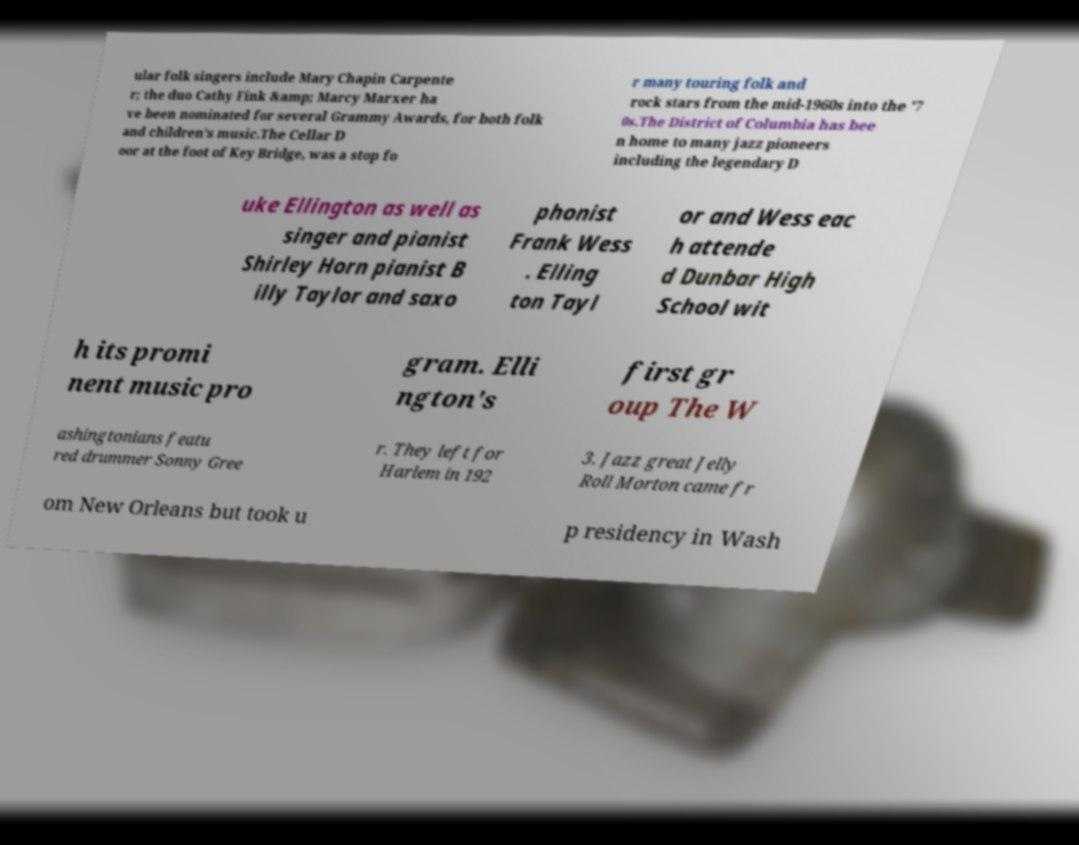There's text embedded in this image that I need extracted. Can you transcribe it verbatim? ular folk singers include Mary Chapin Carpente r; the duo Cathy Fink &amp; Marcy Marxer ha ve been nominated for several Grammy Awards, for both folk and children's music.The Cellar D oor at the foot of Key Bridge, was a stop fo r many touring folk and rock stars from the mid-1960s into the '7 0s.The District of Columbia has bee n home to many jazz pioneers including the legendary D uke Ellington as well as singer and pianist Shirley Horn pianist B illy Taylor and saxo phonist Frank Wess . Elling ton Tayl or and Wess eac h attende d Dunbar High School wit h its promi nent music pro gram. Elli ngton's first gr oup The W ashingtonians featu red drummer Sonny Gree r. They left for Harlem in 192 3. Jazz great Jelly Roll Morton came fr om New Orleans but took u p residency in Wash 